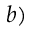Convert formula to latex. <formula><loc_0><loc_0><loc_500><loc_500>b )</formula> 